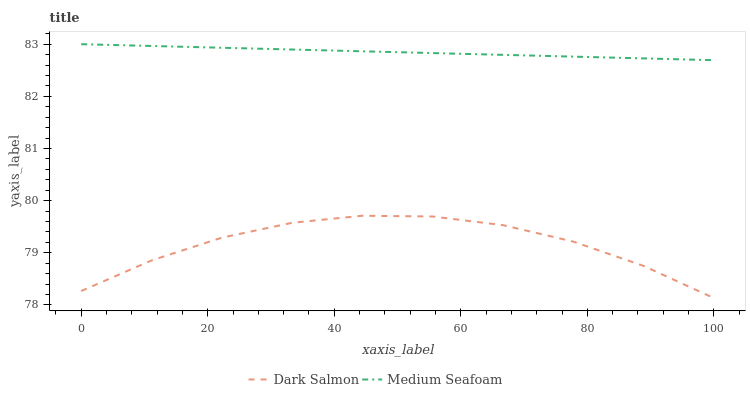Does Dark Salmon have the minimum area under the curve?
Answer yes or no. Yes. Does Medium Seafoam have the maximum area under the curve?
Answer yes or no. Yes. Does Medium Seafoam have the minimum area under the curve?
Answer yes or no. No. Is Medium Seafoam the smoothest?
Answer yes or no. Yes. Is Dark Salmon the roughest?
Answer yes or no. Yes. Is Medium Seafoam the roughest?
Answer yes or no. No. Does Medium Seafoam have the lowest value?
Answer yes or no. No. Does Medium Seafoam have the highest value?
Answer yes or no. Yes. Is Dark Salmon less than Medium Seafoam?
Answer yes or no. Yes. Is Medium Seafoam greater than Dark Salmon?
Answer yes or no. Yes. Does Dark Salmon intersect Medium Seafoam?
Answer yes or no. No. 